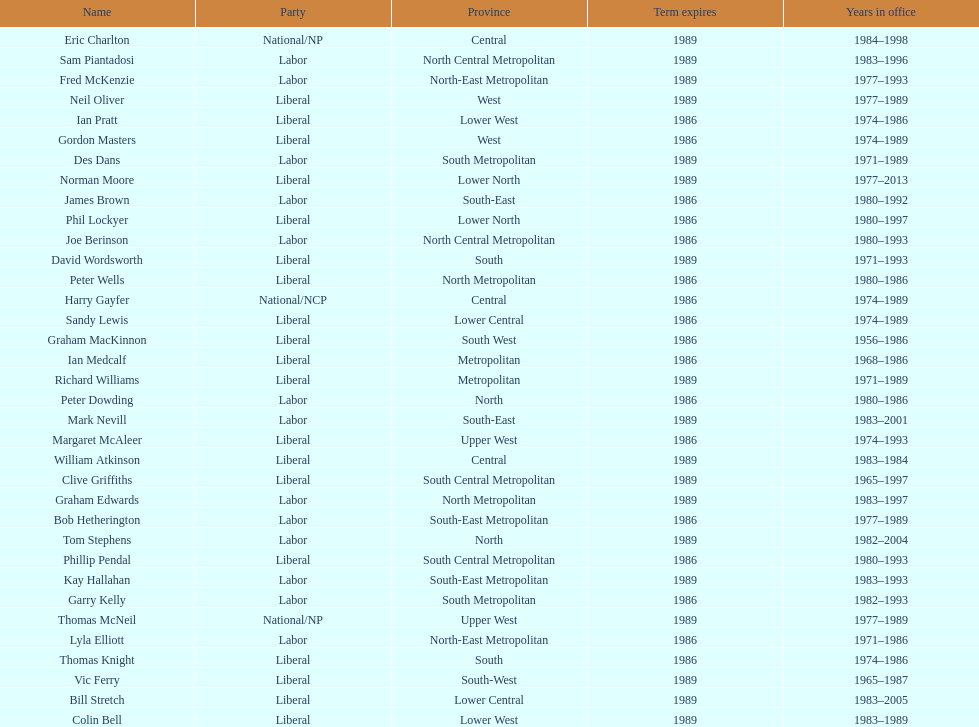What was phil lockyer's party? Liberal. 